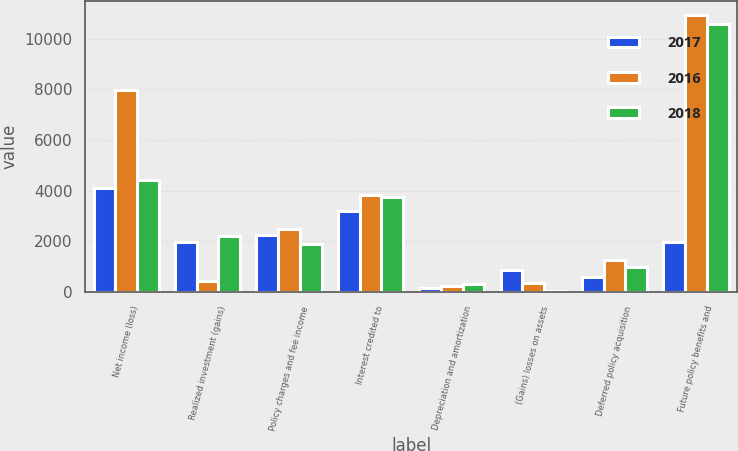Convert chart to OTSL. <chart><loc_0><loc_0><loc_500><loc_500><stacked_bar_chart><ecel><fcel>Net income (loss)<fcel>Realized investment (gains)<fcel>Policy charges and fee income<fcel>Interest credited to<fcel>Depreciation and amortization<fcel>(Gains) losses on assets<fcel>Deferred policy acquisition<fcel>Future policy benefits and<nl><fcel>2017<fcel>4088<fcel>1977<fcel>2248<fcel>3196<fcel>161<fcel>863<fcel>597<fcel>1977<nl><fcel>2016<fcel>7974<fcel>432<fcel>2476<fcel>3822<fcel>222<fcel>336<fcel>1240<fcel>10940<nl><fcel>2018<fcel>4419<fcel>2194<fcel>1907<fcel>3761<fcel>318<fcel>17<fcel>968<fcel>10584<nl></chart> 